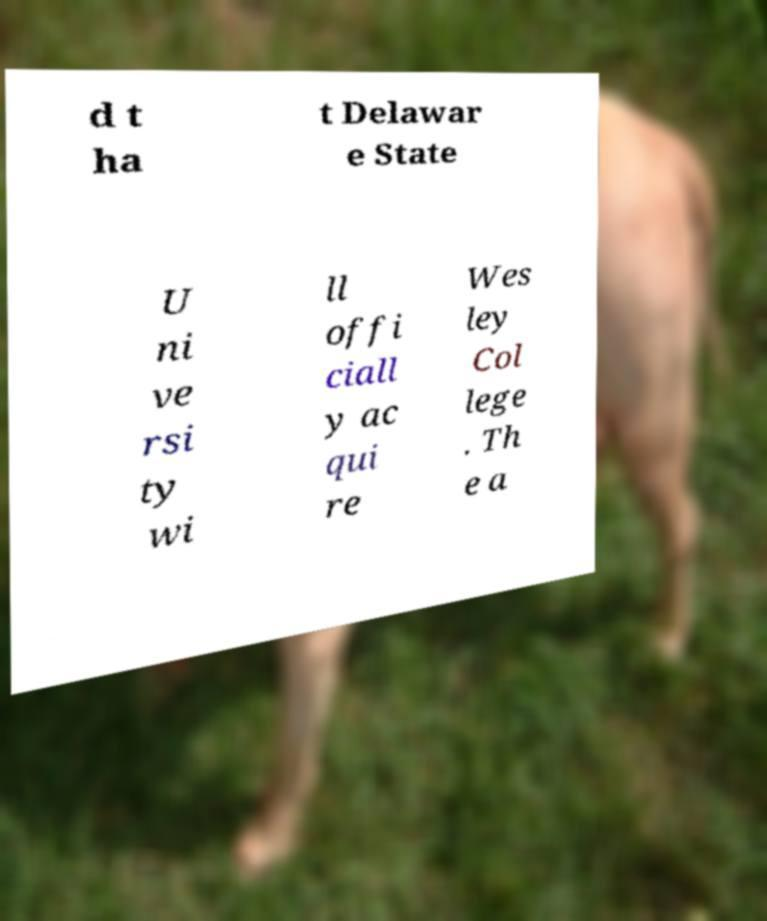For documentation purposes, I need the text within this image transcribed. Could you provide that? d t ha t Delawar e State U ni ve rsi ty wi ll offi ciall y ac qui re Wes ley Col lege . Th e a 